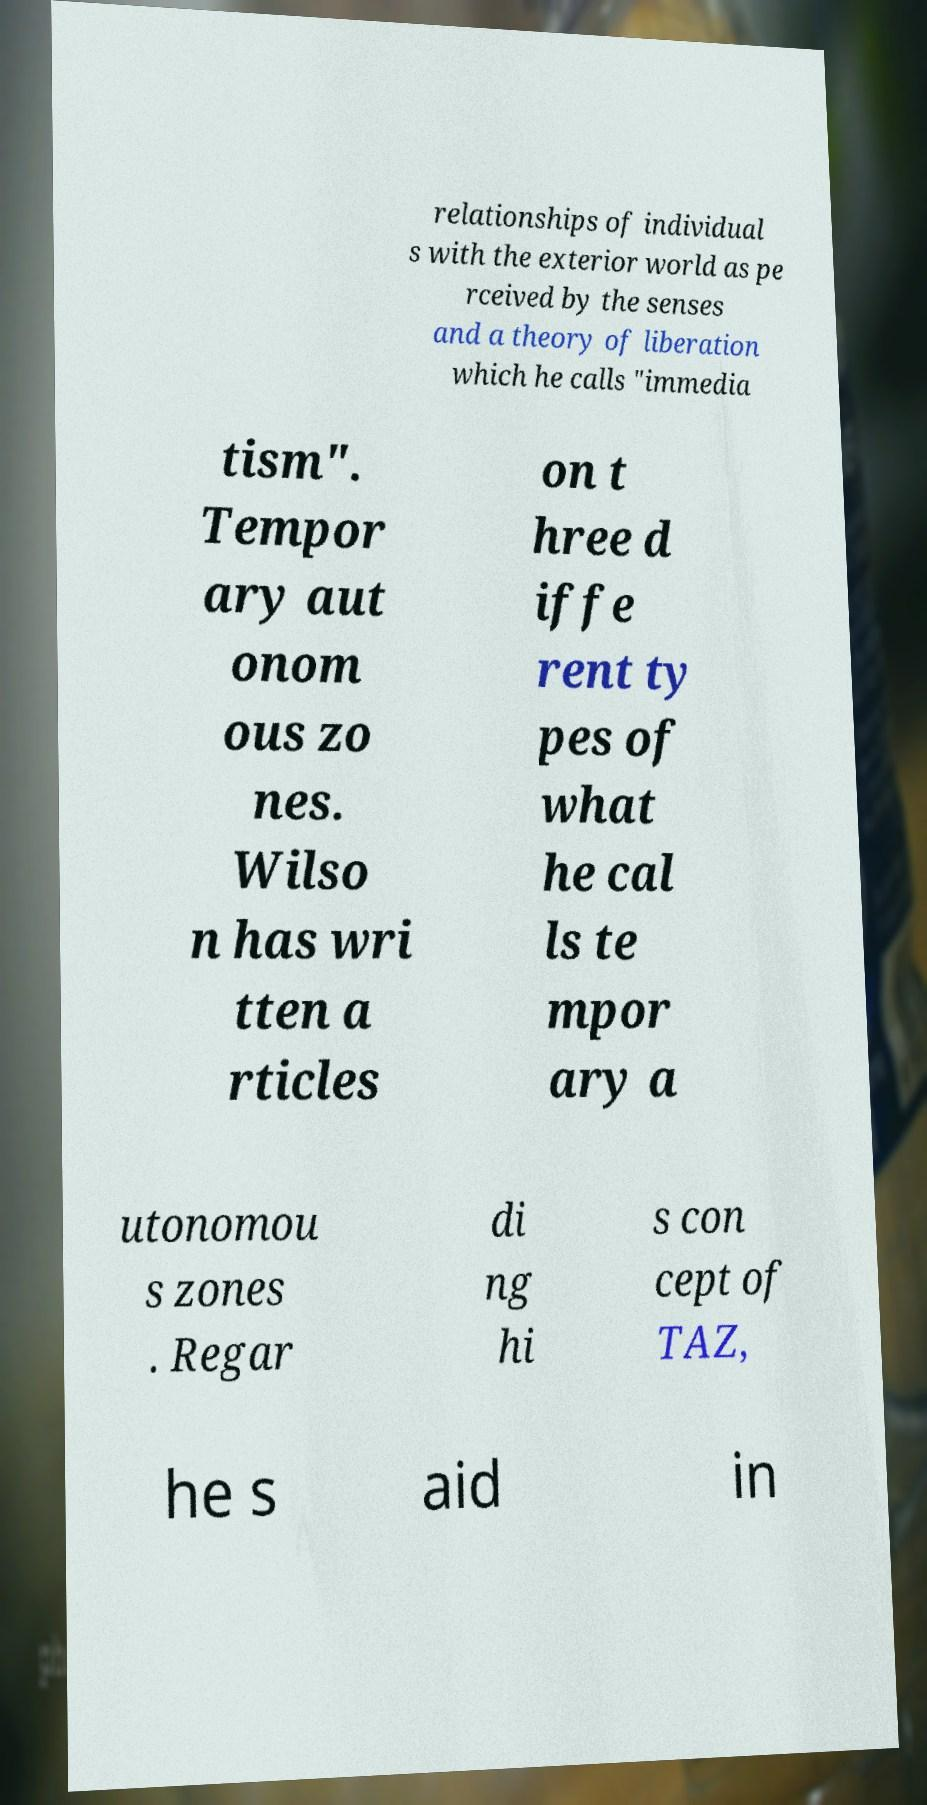I need the written content from this picture converted into text. Can you do that? relationships of individual s with the exterior world as pe rceived by the senses and a theory of liberation which he calls "immedia tism". Tempor ary aut onom ous zo nes. Wilso n has wri tten a rticles on t hree d iffe rent ty pes of what he cal ls te mpor ary a utonomou s zones . Regar di ng hi s con cept of TAZ, he s aid in 